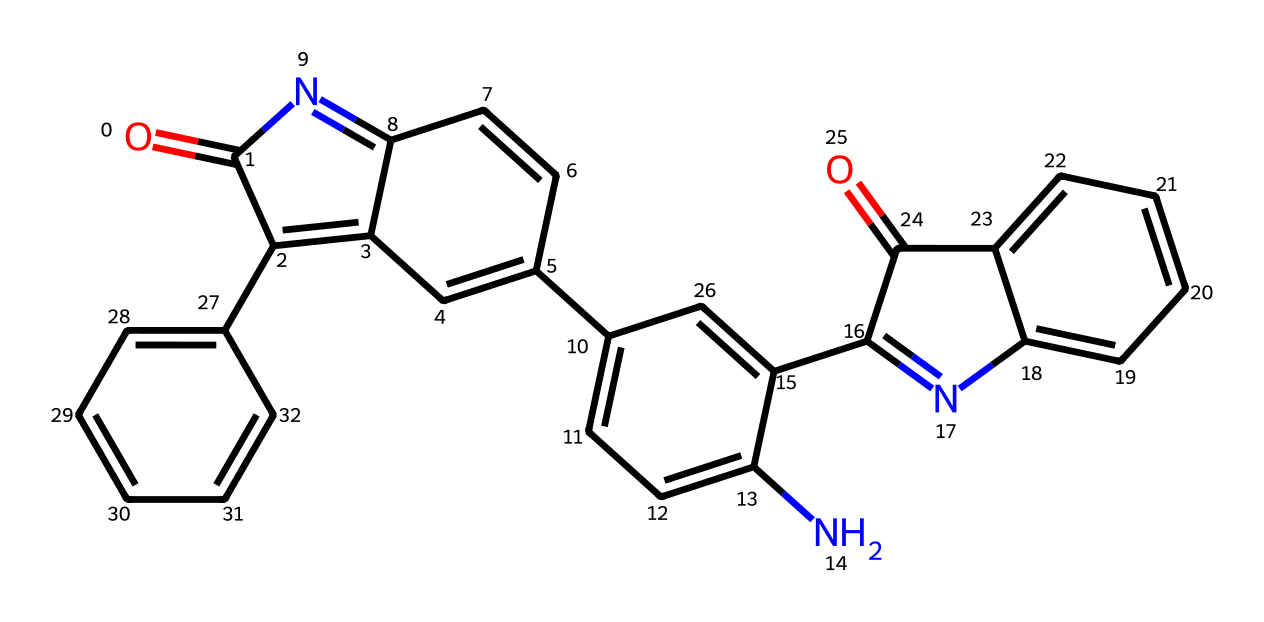What is the base structure of this compound? The compound features multiple interconnected aromatic rings with a nitrogen atom. This indicates a complex arrangement typical of indigo dye.
Answer: indigo How many nitrogen atoms are present in the structure? Counting the nitrogen symbols in the SMILES string shows that there are two nitrogen atoms present in the aromatic compound.
Answer: two What type of bonds are primarily found in this compound? The structure consists mainly of aromatic carbon-carbon bonds, as indicated by the multiple aromatic rings and the presence of alternating single and double bonds.
Answer: aromatic bonds What functional groups are present in this molecule? The molecule contains carbonyl groups (O=C) at specific positions within the rings, indicated by the double-bonded oxygen.
Answer: carbonyl groups What is the degree of unsaturation in this compound? The presence of multiple double bonds in the structure indicates a high degree of unsaturation, typically associated with the presence of aromatic systems. Counting a variety of factors gives a degree of four.
Answer: four Which part of the molecule contributes to its dyeing properties? The extensive conjugated system of alternating double bonds within the aromatic rings allows for significant light absorption, contributing to its color as a dye, primarily in the indigo functional groups.
Answer: conjugated system 